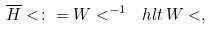<formula> <loc_0><loc_0><loc_500><loc_500>\overline { H } < \colon = W < ^ { - 1 } \ h l t \, W < ,</formula> 